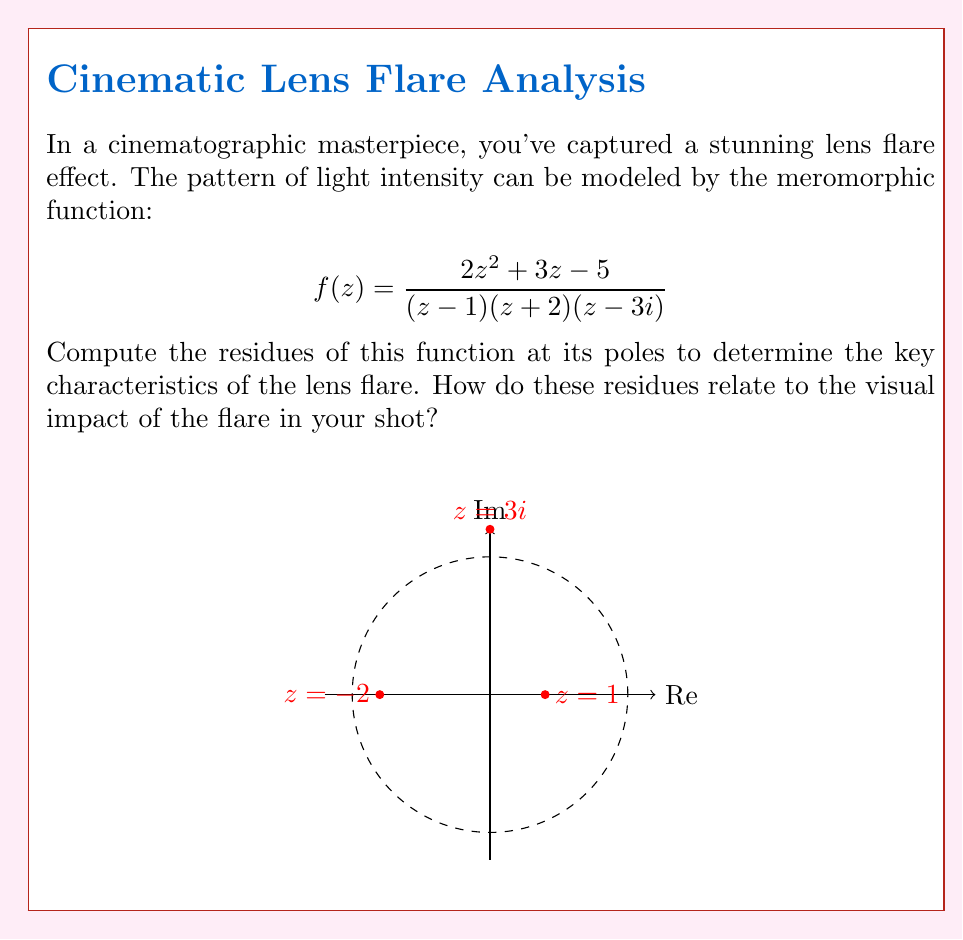Can you solve this math problem? To compute the residues, we'll use the formula for simple poles:

$$\text{Res}(f,a) = \lim_{z \to a} (z-a)f(z)$$

1. At $z=1$:
   $$\text{Res}(f,1) = \lim_{z \to 1} (z-1)\frac{2z^2 + 3z - 5}{(z-1)(z+2)(z-3i)}$$
   $$= \lim_{z \to 1} \frac{2z^2 + 3z - 5}{(z+2)(z-3i)}$$
   $$= \frac{2(1)^2 + 3(1) - 5}{(1+2)(1-3i)} = \frac{0}{3(1-3i)} = 0$$

2. At $z=-2$:
   $$\text{Res}(f,-2) = \lim_{z \to -2} (z+2)\frac{2z^2 + 3z - 5}{(z-1)(z+2)(z-3i)}$$
   $$= \lim_{z \to -2} \frac{2z^2 + 3z - 5}{(z-1)(z-3i)}$$
   $$= \frac{2(-2)^2 + 3(-2) - 5}{(-3)(-2-3i)} = \frac{8-6-5}{3(2+3i)} = \frac{-1}{3(2+3i)}$$

3. At $z=3i$:
   $$\text{Res}(f,3i) = \lim_{z \to 3i} (z-3i)\frac{2z^2 + 3z - 5}{(z-1)(z+2)(z-3i)}$$
   $$= \lim_{z \to 3i} \frac{2z^2 + 3z - 5}{(z-1)(z+2)}$$
   $$= \frac{2(3i)^2 + 3(3i) - 5}{(3i-1)(3i+2)} = \frac{-18 + 9i - 5}{(3i-1)(3i+2)} = \frac{-23 + 9i}{-10 + 5i}$$

The residues represent the "strength" of the singularities in the lens flare model. The zero residue at $z=1$ suggests no contribution to the flare from this point. The non-zero residues at $z=-2$ and $z=3i$ indicate significant contributions to the flare pattern, with the imaginary component at $z=3i$ potentially creating an iridescent or chromatic effect in the flare.
Answer: $\text{Res}(f,1) = 0$, $\text{Res}(f,-2) = \frac{-1}{3(2+3i)}$, $\text{Res}(f,3i) = \frac{-23 + 9i}{-10 + 5i}$ 